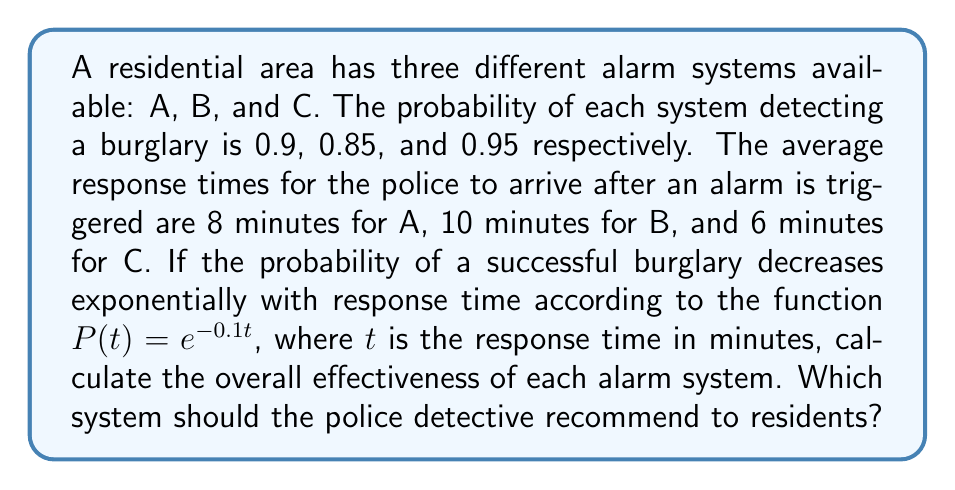Can you answer this question? To solve this problem, we need to follow these steps:

1) First, let's calculate the probability of a successful burglary for each alarm system based on their response times:

   System A: $P(8) = e^{-0.1 \cdot 8} = e^{-0.8} \approx 0.4493$
   System B: $P(10) = e^{-0.1 \cdot 10} = e^{-1} \approx 0.3679$
   System C: $P(6) = e^{-0.1 \cdot 6} = e^{-0.6} \approx 0.5488$

2) Now, we need to consider the probability of the alarm system detecting the burglary in the first place:

   System A: 0.9
   System B: 0.85
   System C: 0.95

3) The overall effectiveness of each system is the probability that it detects the burglary multiplied by the probability that the burglary is unsuccessful given the response time:

   System A: $0.9 \cdot (1 - 0.4493) = 0.9 \cdot 0.5507 = 0.4956$
   System B: $0.85 \cdot (1 - 0.3679) = 0.85 \cdot 0.6321 = 0.5373$
   System C: $0.95 \cdot (1 - 0.5488) = 0.95 \cdot 0.4512 = 0.4286$

4) Comparing the effectiveness:

   System B (0.5373) > System A (0.4956) > System C (0.4286)

Therefore, the police detective should recommend System B to residents, as it has the highest overall effectiveness in preventing successful burglaries.
Answer: System B, with an effectiveness of 0.5373 